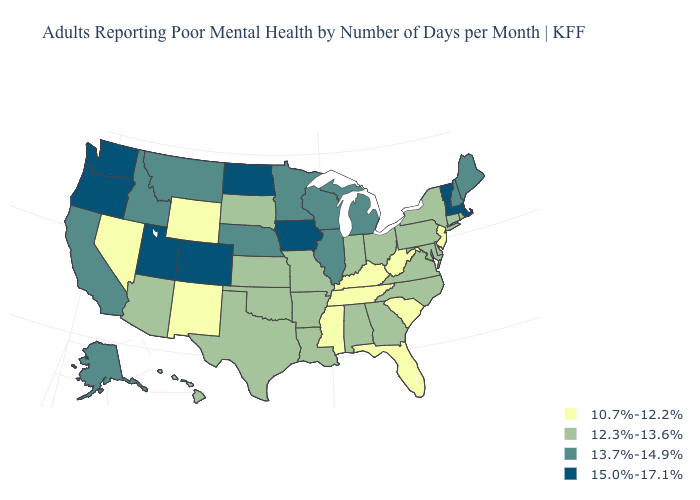Does Illinois have a higher value than Rhode Island?
Concise answer only. Yes. What is the value of Ohio?
Keep it brief. 12.3%-13.6%. Name the states that have a value in the range 13.7%-14.9%?
Give a very brief answer. Alaska, California, Idaho, Illinois, Maine, Michigan, Minnesota, Montana, Nebraska, New Hampshire, Wisconsin. What is the highest value in the MidWest ?
Be succinct. 15.0%-17.1%. Among the states that border California , which have the highest value?
Write a very short answer. Oregon. Name the states that have a value in the range 12.3%-13.6%?
Give a very brief answer. Alabama, Arizona, Arkansas, Connecticut, Delaware, Georgia, Hawaii, Indiana, Kansas, Louisiana, Maryland, Missouri, New York, North Carolina, Ohio, Oklahoma, Pennsylvania, Rhode Island, South Dakota, Texas, Virginia. Does the first symbol in the legend represent the smallest category?
Be succinct. Yes. Name the states that have a value in the range 10.7%-12.2%?
Answer briefly. Florida, Kentucky, Mississippi, Nevada, New Jersey, New Mexico, South Carolina, Tennessee, West Virginia, Wyoming. Is the legend a continuous bar?
Be succinct. No. Among the states that border North Dakota , which have the highest value?
Quick response, please. Minnesota, Montana. Name the states that have a value in the range 15.0%-17.1%?
Be succinct. Colorado, Iowa, Massachusetts, North Dakota, Oregon, Utah, Vermont, Washington. Which states hav the highest value in the Northeast?
Write a very short answer. Massachusetts, Vermont. Which states have the highest value in the USA?
Concise answer only. Colorado, Iowa, Massachusetts, North Dakota, Oregon, Utah, Vermont, Washington. Does the first symbol in the legend represent the smallest category?
Write a very short answer. Yes. What is the lowest value in states that border Colorado?
Give a very brief answer. 10.7%-12.2%. 